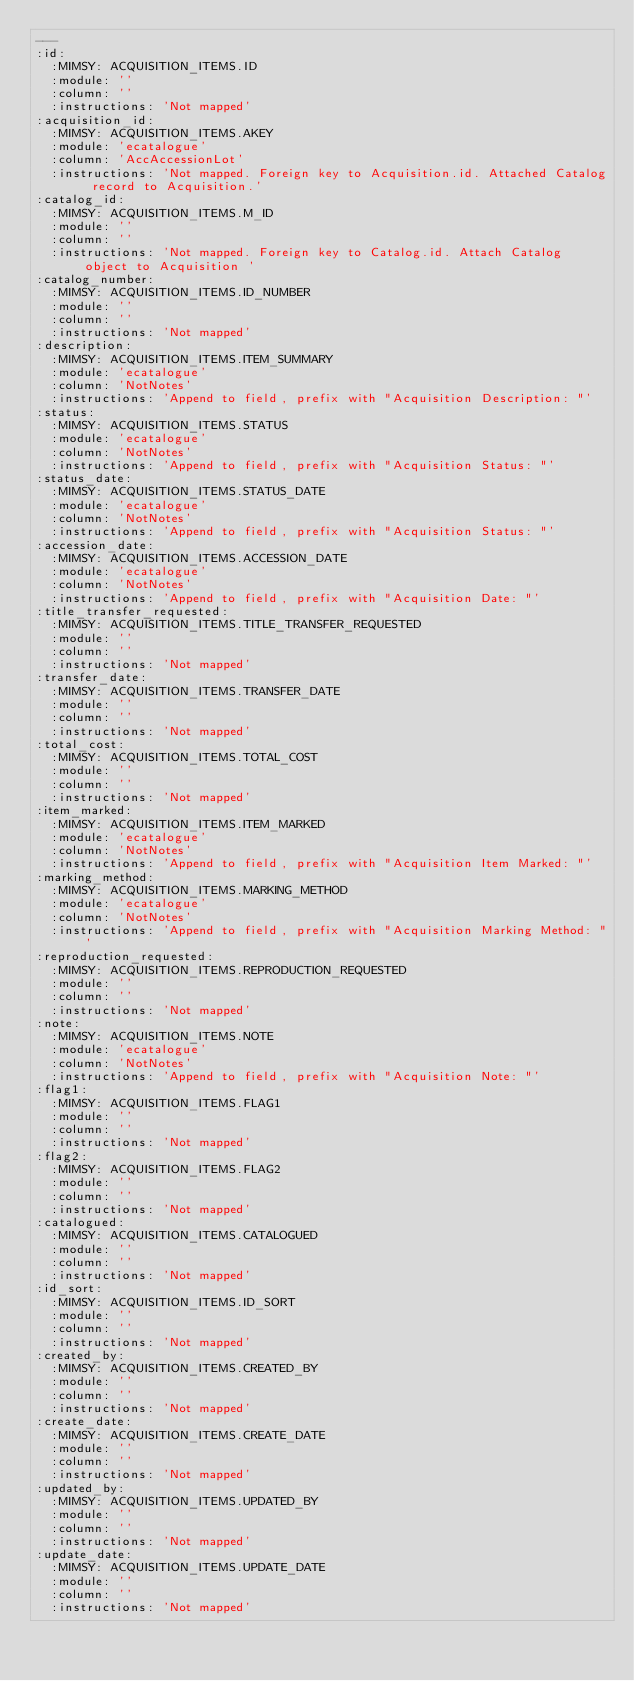<code> <loc_0><loc_0><loc_500><loc_500><_YAML_>---
:id:
  :MIMSY: ACQUISITION_ITEMS.ID
  :module: ''
  :column: ''
  :instructions: 'Not mapped'
:acquisition_id:
  :MIMSY: ACQUISITION_ITEMS.AKEY
  :module: 'ecatalogue'
  :column: 'AccAccessionLot'
  :instructions: 'Not mapped. Foreign key to Acquisition.id. Attached Catalog record to Acquisition.'
:catalog_id:
  :MIMSY: ACQUISITION_ITEMS.M_ID
  :module: ''
  :column: ''
  :instructions: 'Not mapped. Foreign key to Catalog.id. Attach Catalog object to Acquisition '
:catalog_number:
  :MIMSY: ACQUISITION_ITEMS.ID_NUMBER
  :module: ''
  :column: ''
  :instructions: 'Not mapped'
:description:
  :MIMSY: ACQUISITION_ITEMS.ITEM_SUMMARY
  :module: 'ecatalogue'
  :column: 'NotNotes'
  :instructions: 'Append to field, prefix with "Acquisition Description: "'
:status:
  :MIMSY: ACQUISITION_ITEMS.STATUS
  :module: 'ecatalogue'
  :column: 'NotNotes'
  :instructions: 'Append to field, prefix with "Acquisition Status: "'
:status_date:
  :MIMSY: ACQUISITION_ITEMS.STATUS_DATE
  :module: 'ecatalogue'
  :column: 'NotNotes'
  :instructions: 'Append to field, prefix with "Acquisition Status: "'
:accession_date:
  :MIMSY: ACQUISITION_ITEMS.ACCESSION_DATE
  :module: 'ecatalogue'
  :column: 'NotNotes'
  :instructions: 'Append to field, prefix with "Acquisition Date: "'
:title_transfer_requested:
  :MIMSY: ACQUISITION_ITEMS.TITLE_TRANSFER_REQUESTED
  :module: ''
  :column: ''
  :instructions: 'Not mapped'
:transfer_date:
  :MIMSY: ACQUISITION_ITEMS.TRANSFER_DATE
  :module: ''
  :column: ''
  :instructions: 'Not mapped'
:total_cost:
  :MIMSY: ACQUISITION_ITEMS.TOTAL_COST
  :module: ''
  :column: ''
  :instructions: 'Not mapped'
:item_marked:
  :MIMSY: ACQUISITION_ITEMS.ITEM_MARKED
  :module: 'ecatalogue'
  :column: 'NotNotes'
  :instructions: 'Append to field, prefix with "Acquisition Item Marked: "'
:marking_method:
  :MIMSY: ACQUISITION_ITEMS.MARKING_METHOD
  :module: 'ecatalogue'
  :column: 'NotNotes'
  :instructions: 'Append to field, prefix with "Acquisition Marking Method: "'
:reproduction_requested:
  :MIMSY: ACQUISITION_ITEMS.REPRODUCTION_REQUESTED
  :module: ''
  :column: ''
  :instructions: 'Not mapped'
:note:
  :MIMSY: ACQUISITION_ITEMS.NOTE
  :module: 'ecatalogue'
  :column: 'NotNotes'
  :instructions: 'Append to field, prefix with "Acquisition Note: "'
:flag1:
  :MIMSY: ACQUISITION_ITEMS.FLAG1
  :module: ''
  :column: ''
  :instructions: 'Not mapped'
:flag2:
  :MIMSY: ACQUISITION_ITEMS.FLAG2
  :module: ''
  :column: ''
  :instructions: 'Not mapped'
:catalogued:
  :MIMSY: ACQUISITION_ITEMS.CATALOGUED
  :module: ''
  :column: ''
  :instructions: 'Not mapped'
:id_sort:
  :MIMSY: ACQUISITION_ITEMS.ID_SORT
  :module: ''
  :column: ''
  :instructions: 'Not mapped'
:created_by:
  :MIMSY: ACQUISITION_ITEMS.CREATED_BY
  :module: ''
  :column: ''
  :instructions: 'Not mapped'
:create_date:
  :MIMSY: ACQUISITION_ITEMS.CREATE_DATE
  :module: ''
  :column: ''
  :instructions: 'Not mapped'
:updated_by:
  :MIMSY: ACQUISITION_ITEMS.UPDATED_BY
  :module: ''
  :column: ''
  :instructions: 'Not mapped'
:update_date:
  :MIMSY: ACQUISITION_ITEMS.UPDATE_DATE
  :module: ''
  :column: ''
  :instructions: 'Not mapped'
</code> 